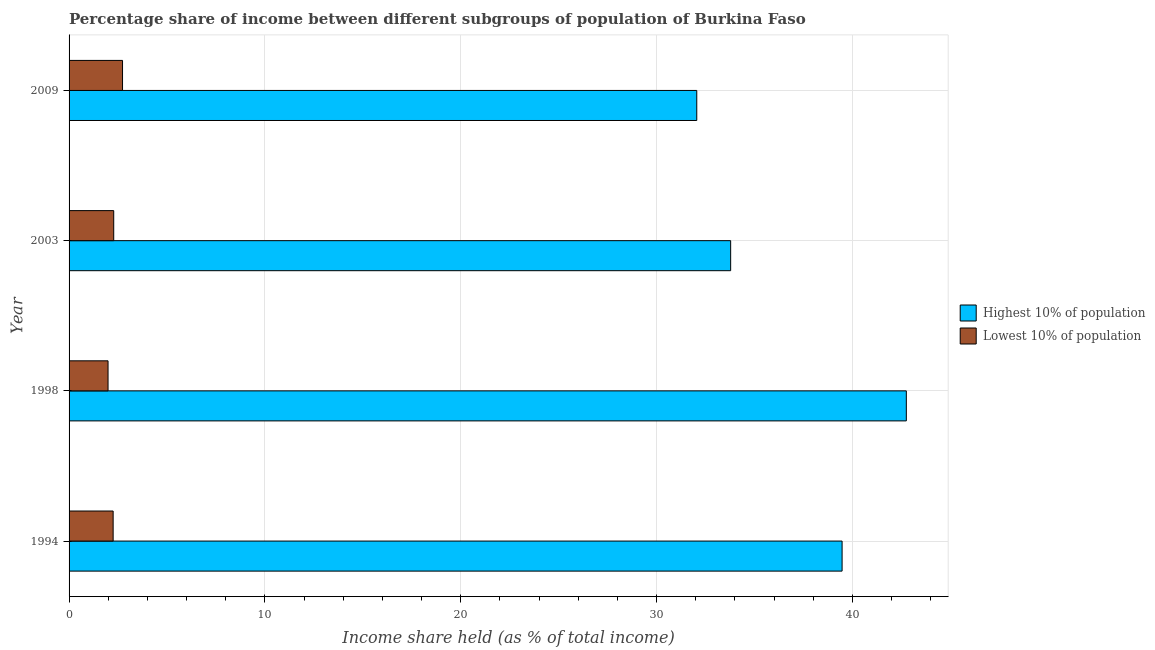How many groups of bars are there?
Offer a terse response. 4. Are the number of bars per tick equal to the number of legend labels?
Your answer should be compact. Yes. Are the number of bars on each tick of the Y-axis equal?
Your response must be concise. Yes. How many bars are there on the 2nd tick from the top?
Your answer should be compact. 2. How many bars are there on the 3rd tick from the bottom?
Provide a succinct answer. 2. What is the income share held by highest 10% of the population in 1994?
Ensure brevity in your answer.  39.47. Across all years, what is the maximum income share held by lowest 10% of the population?
Your answer should be compact. 2.73. Across all years, what is the minimum income share held by highest 10% of the population?
Ensure brevity in your answer.  32.05. What is the total income share held by lowest 10% of the population in the graph?
Offer a very short reply. 9.25. What is the difference between the income share held by lowest 10% of the population in 1998 and that in 2009?
Provide a succinct answer. -0.74. What is the difference between the income share held by lowest 10% of the population in 2009 and the income share held by highest 10% of the population in 2003?
Offer a very short reply. -31.05. What is the average income share held by highest 10% of the population per year?
Offer a very short reply. 37.01. In the year 1994, what is the difference between the income share held by highest 10% of the population and income share held by lowest 10% of the population?
Your response must be concise. 37.22. What is the ratio of the income share held by lowest 10% of the population in 1998 to that in 2009?
Give a very brief answer. 0.73. Is the difference between the income share held by lowest 10% of the population in 2003 and 2009 greater than the difference between the income share held by highest 10% of the population in 2003 and 2009?
Give a very brief answer. No. What is the difference between the highest and the second highest income share held by highest 10% of the population?
Provide a short and direct response. 3.28. What is the difference between the highest and the lowest income share held by lowest 10% of the population?
Offer a terse response. 0.74. In how many years, is the income share held by lowest 10% of the population greater than the average income share held by lowest 10% of the population taken over all years?
Keep it short and to the point. 1. Is the sum of the income share held by lowest 10% of the population in 1998 and 2003 greater than the maximum income share held by highest 10% of the population across all years?
Keep it short and to the point. No. What does the 2nd bar from the top in 1998 represents?
Provide a short and direct response. Highest 10% of population. What does the 2nd bar from the bottom in 1998 represents?
Keep it short and to the point. Lowest 10% of population. How many years are there in the graph?
Give a very brief answer. 4. How many legend labels are there?
Make the answer very short. 2. What is the title of the graph?
Ensure brevity in your answer.  Percentage share of income between different subgroups of population of Burkina Faso. What is the label or title of the X-axis?
Offer a terse response. Income share held (as % of total income). What is the label or title of the Y-axis?
Your answer should be compact. Year. What is the Income share held (as % of total income) of Highest 10% of population in 1994?
Your answer should be very brief. 39.47. What is the Income share held (as % of total income) in Lowest 10% of population in 1994?
Your answer should be very brief. 2.25. What is the Income share held (as % of total income) of Highest 10% of population in 1998?
Offer a very short reply. 42.75. What is the Income share held (as % of total income) in Lowest 10% of population in 1998?
Provide a succinct answer. 1.99. What is the Income share held (as % of total income) in Highest 10% of population in 2003?
Provide a short and direct response. 33.78. What is the Income share held (as % of total income) in Lowest 10% of population in 2003?
Offer a very short reply. 2.28. What is the Income share held (as % of total income) in Highest 10% of population in 2009?
Offer a very short reply. 32.05. What is the Income share held (as % of total income) of Lowest 10% of population in 2009?
Make the answer very short. 2.73. Across all years, what is the maximum Income share held (as % of total income) of Highest 10% of population?
Make the answer very short. 42.75. Across all years, what is the maximum Income share held (as % of total income) of Lowest 10% of population?
Provide a short and direct response. 2.73. Across all years, what is the minimum Income share held (as % of total income) in Highest 10% of population?
Keep it short and to the point. 32.05. Across all years, what is the minimum Income share held (as % of total income) in Lowest 10% of population?
Your answer should be compact. 1.99. What is the total Income share held (as % of total income) of Highest 10% of population in the graph?
Ensure brevity in your answer.  148.05. What is the total Income share held (as % of total income) of Lowest 10% of population in the graph?
Ensure brevity in your answer.  9.25. What is the difference between the Income share held (as % of total income) of Highest 10% of population in 1994 and that in 1998?
Your answer should be compact. -3.28. What is the difference between the Income share held (as % of total income) in Lowest 10% of population in 1994 and that in 1998?
Offer a very short reply. 0.26. What is the difference between the Income share held (as % of total income) of Highest 10% of population in 1994 and that in 2003?
Provide a short and direct response. 5.69. What is the difference between the Income share held (as % of total income) in Lowest 10% of population in 1994 and that in 2003?
Provide a short and direct response. -0.03. What is the difference between the Income share held (as % of total income) in Highest 10% of population in 1994 and that in 2009?
Offer a very short reply. 7.42. What is the difference between the Income share held (as % of total income) in Lowest 10% of population in 1994 and that in 2009?
Your answer should be compact. -0.48. What is the difference between the Income share held (as % of total income) of Highest 10% of population in 1998 and that in 2003?
Your answer should be very brief. 8.97. What is the difference between the Income share held (as % of total income) of Lowest 10% of population in 1998 and that in 2003?
Provide a short and direct response. -0.29. What is the difference between the Income share held (as % of total income) in Highest 10% of population in 1998 and that in 2009?
Give a very brief answer. 10.7. What is the difference between the Income share held (as % of total income) in Lowest 10% of population in 1998 and that in 2009?
Offer a terse response. -0.74. What is the difference between the Income share held (as % of total income) of Highest 10% of population in 2003 and that in 2009?
Provide a succinct answer. 1.73. What is the difference between the Income share held (as % of total income) of Lowest 10% of population in 2003 and that in 2009?
Offer a terse response. -0.45. What is the difference between the Income share held (as % of total income) in Highest 10% of population in 1994 and the Income share held (as % of total income) in Lowest 10% of population in 1998?
Provide a succinct answer. 37.48. What is the difference between the Income share held (as % of total income) in Highest 10% of population in 1994 and the Income share held (as % of total income) in Lowest 10% of population in 2003?
Offer a terse response. 37.19. What is the difference between the Income share held (as % of total income) in Highest 10% of population in 1994 and the Income share held (as % of total income) in Lowest 10% of population in 2009?
Make the answer very short. 36.74. What is the difference between the Income share held (as % of total income) in Highest 10% of population in 1998 and the Income share held (as % of total income) in Lowest 10% of population in 2003?
Offer a terse response. 40.47. What is the difference between the Income share held (as % of total income) in Highest 10% of population in 1998 and the Income share held (as % of total income) in Lowest 10% of population in 2009?
Your answer should be very brief. 40.02. What is the difference between the Income share held (as % of total income) of Highest 10% of population in 2003 and the Income share held (as % of total income) of Lowest 10% of population in 2009?
Provide a short and direct response. 31.05. What is the average Income share held (as % of total income) of Highest 10% of population per year?
Make the answer very short. 37.01. What is the average Income share held (as % of total income) of Lowest 10% of population per year?
Your answer should be compact. 2.31. In the year 1994, what is the difference between the Income share held (as % of total income) in Highest 10% of population and Income share held (as % of total income) in Lowest 10% of population?
Ensure brevity in your answer.  37.22. In the year 1998, what is the difference between the Income share held (as % of total income) in Highest 10% of population and Income share held (as % of total income) in Lowest 10% of population?
Make the answer very short. 40.76. In the year 2003, what is the difference between the Income share held (as % of total income) of Highest 10% of population and Income share held (as % of total income) of Lowest 10% of population?
Provide a succinct answer. 31.5. In the year 2009, what is the difference between the Income share held (as % of total income) of Highest 10% of population and Income share held (as % of total income) of Lowest 10% of population?
Provide a short and direct response. 29.32. What is the ratio of the Income share held (as % of total income) of Highest 10% of population in 1994 to that in 1998?
Provide a short and direct response. 0.92. What is the ratio of the Income share held (as % of total income) in Lowest 10% of population in 1994 to that in 1998?
Keep it short and to the point. 1.13. What is the ratio of the Income share held (as % of total income) of Highest 10% of population in 1994 to that in 2003?
Your response must be concise. 1.17. What is the ratio of the Income share held (as % of total income) of Lowest 10% of population in 1994 to that in 2003?
Provide a succinct answer. 0.99. What is the ratio of the Income share held (as % of total income) of Highest 10% of population in 1994 to that in 2009?
Offer a terse response. 1.23. What is the ratio of the Income share held (as % of total income) of Lowest 10% of population in 1994 to that in 2009?
Ensure brevity in your answer.  0.82. What is the ratio of the Income share held (as % of total income) of Highest 10% of population in 1998 to that in 2003?
Offer a terse response. 1.27. What is the ratio of the Income share held (as % of total income) of Lowest 10% of population in 1998 to that in 2003?
Keep it short and to the point. 0.87. What is the ratio of the Income share held (as % of total income) in Highest 10% of population in 1998 to that in 2009?
Make the answer very short. 1.33. What is the ratio of the Income share held (as % of total income) in Lowest 10% of population in 1998 to that in 2009?
Give a very brief answer. 0.73. What is the ratio of the Income share held (as % of total income) in Highest 10% of population in 2003 to that in 2009?
Offer a terse response. 1.05. What is the ratio of the Income share held (as % of total income) of Lowest 10% of population in 2003 to that in 2009?
Offer a terse response. 0.84. What is the difference between the highest and the second highest Income share held (as % of total income) of Highest 10% of population?
Offer a very short reply. 3.28. What is the difference between the highest and the second highest Income share held (as % of total income) in Lowest 10% of population?
Your answer should be very brief. 0.45. What is the difference between the highest and the lowest Income share held (as % of total income) in Lowest 10% of population?
Your response must be concise. 0.74. 